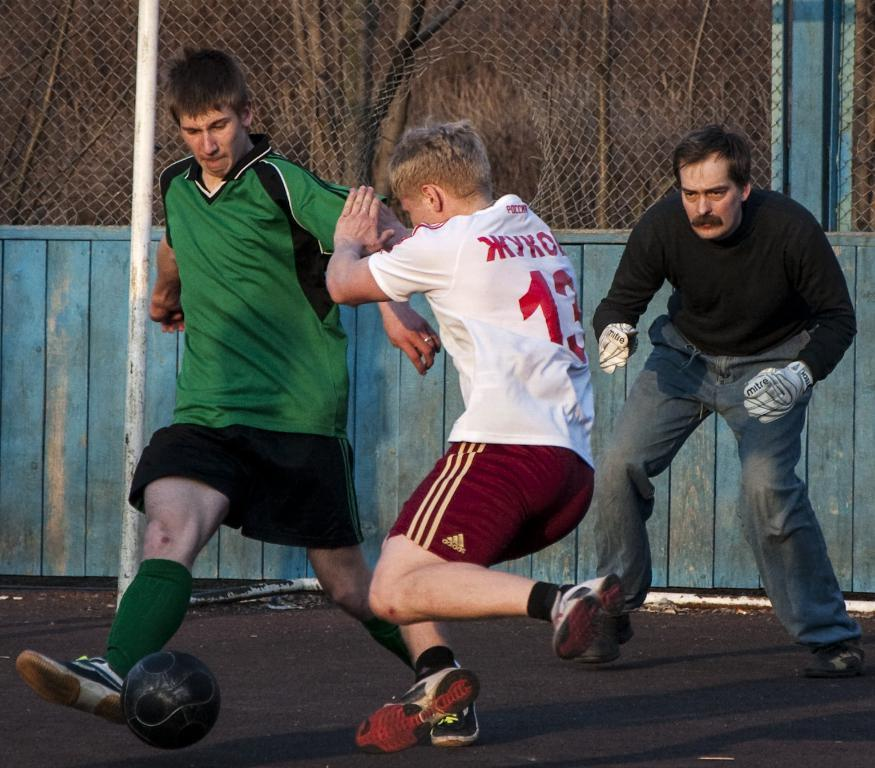How many people are playing football in the image? There are two boys playing football in the image. What is the role of the person in the image who is not playing football? The person in the image who is not playing football is a referee, who is watching the boys play. What is the boundary of the play field in the image? The play field is surrounded by a fence. What type of cough medicine is the referee holding in the image? There is no cough medicine present in the image; the referee is simply watching the boys play football. 